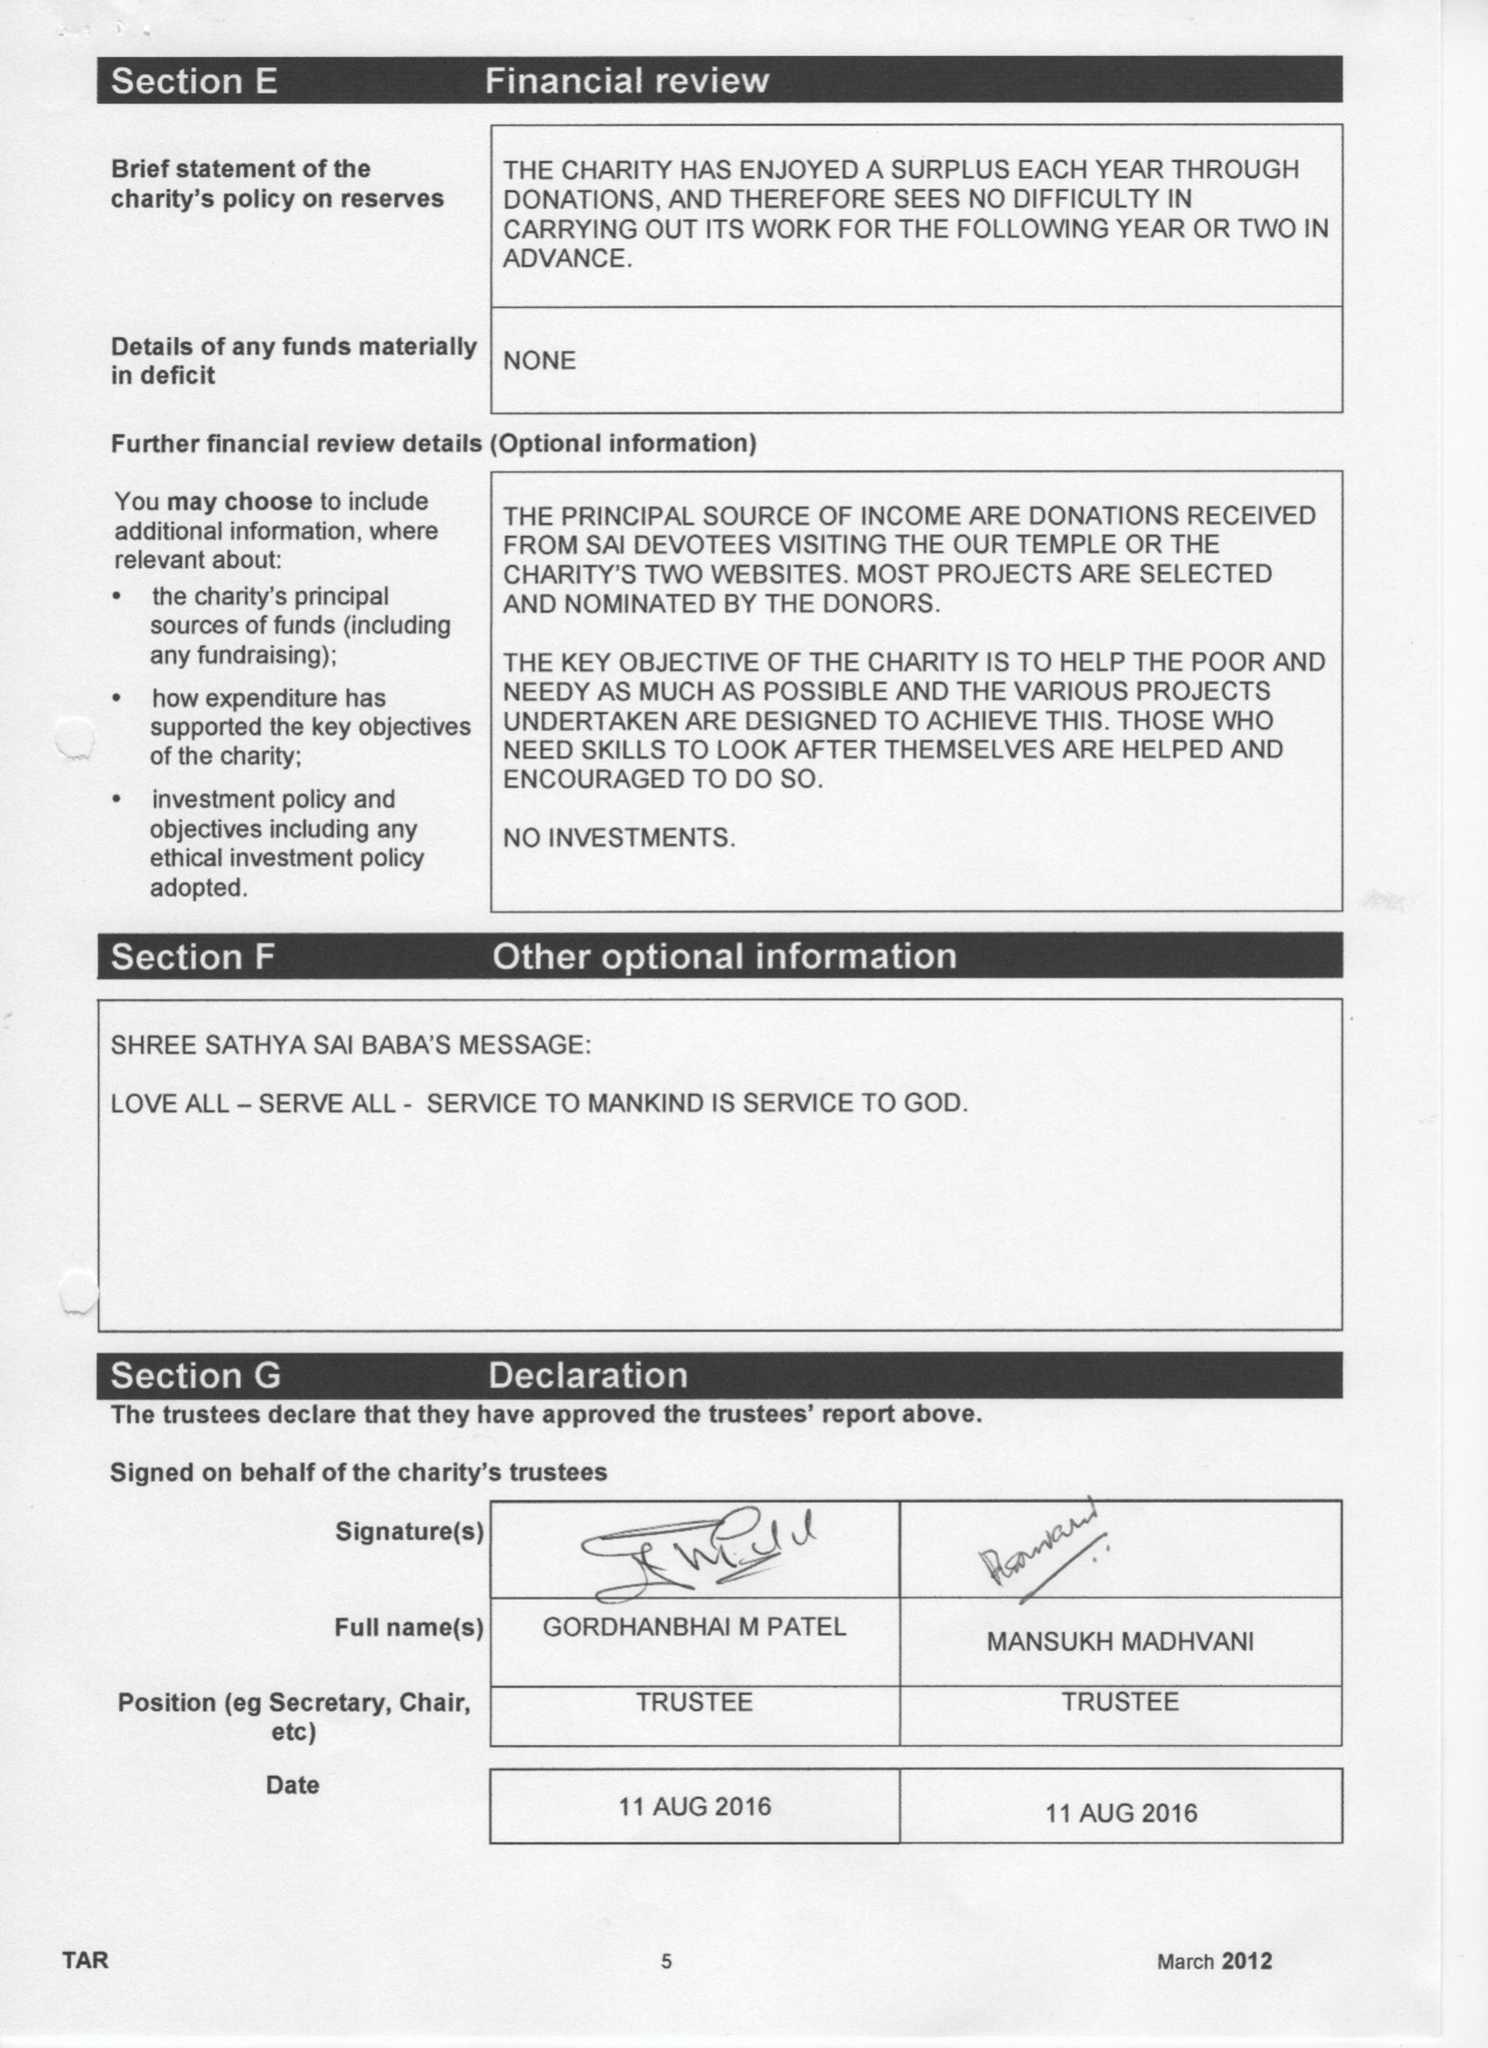What is the value for the address__street_line?
Answer the question using a single word or phrase. 8 THE CROSS WAY 